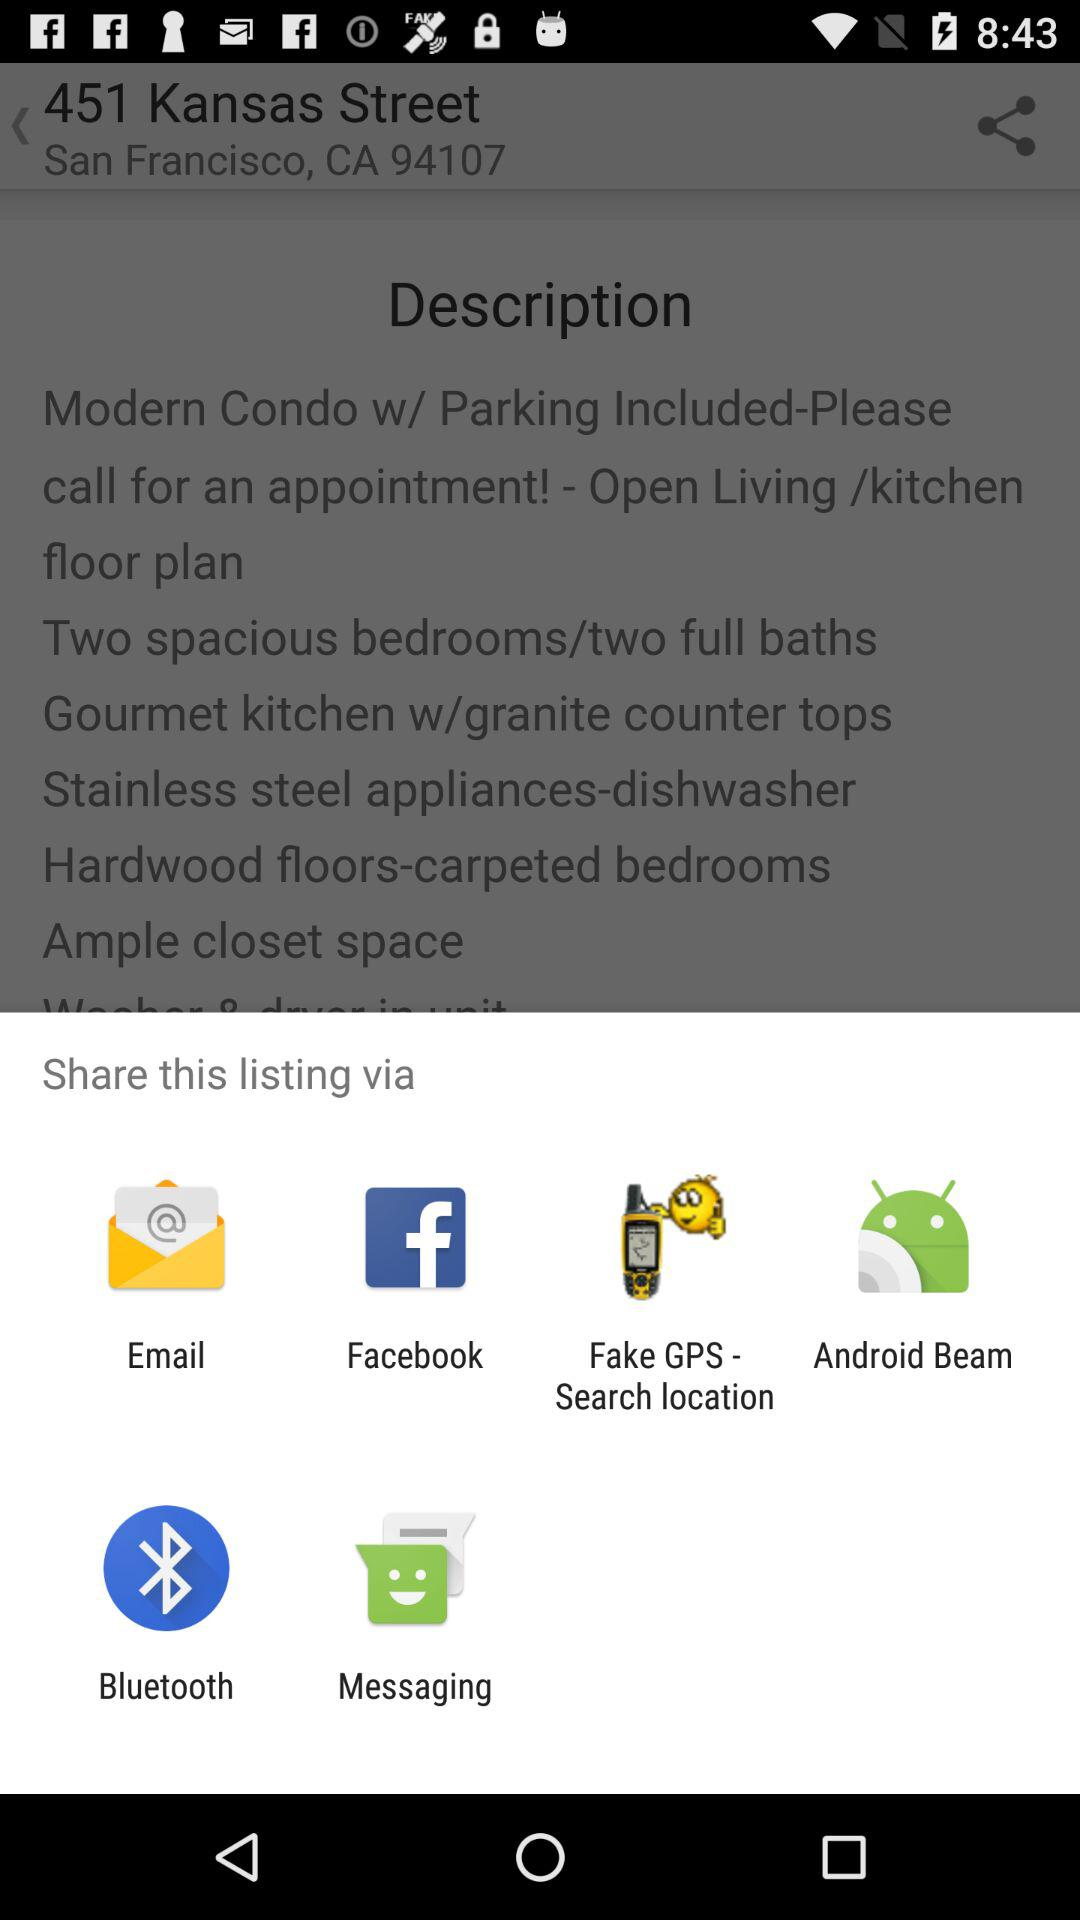Which version of the application is this?
When the provided information is insufficient, respond with <no answer>. <no answer> 